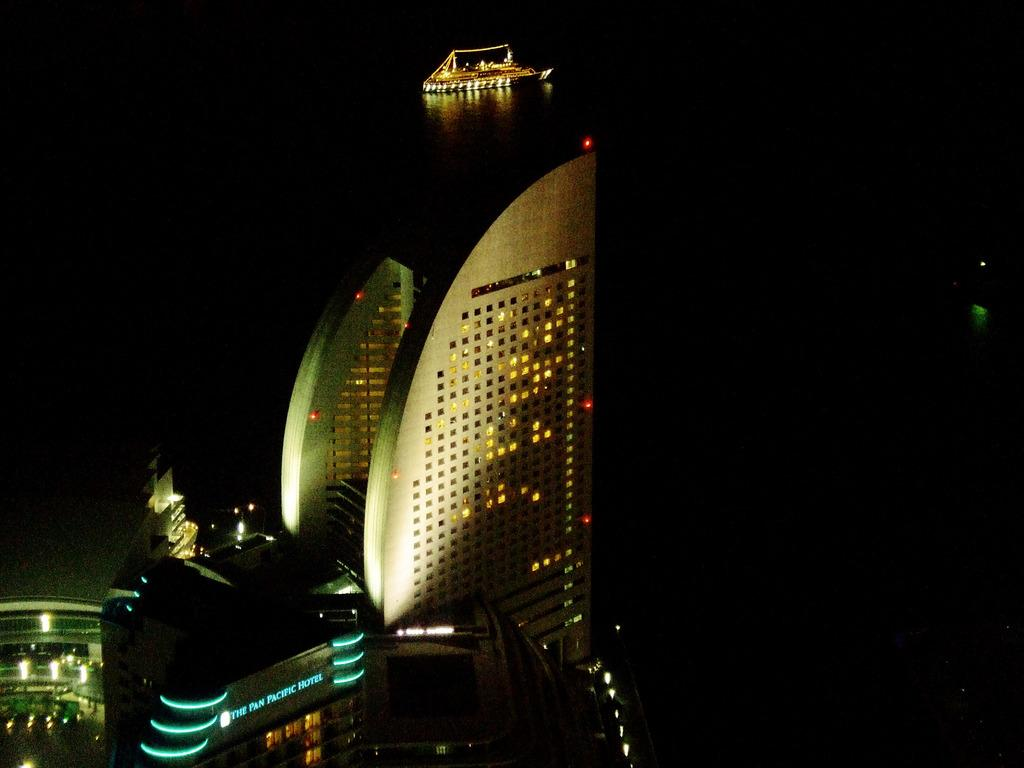<image>
Provide a brief description of the given image. Large building for "The Pan Pacific Hote" standing in the dark. 